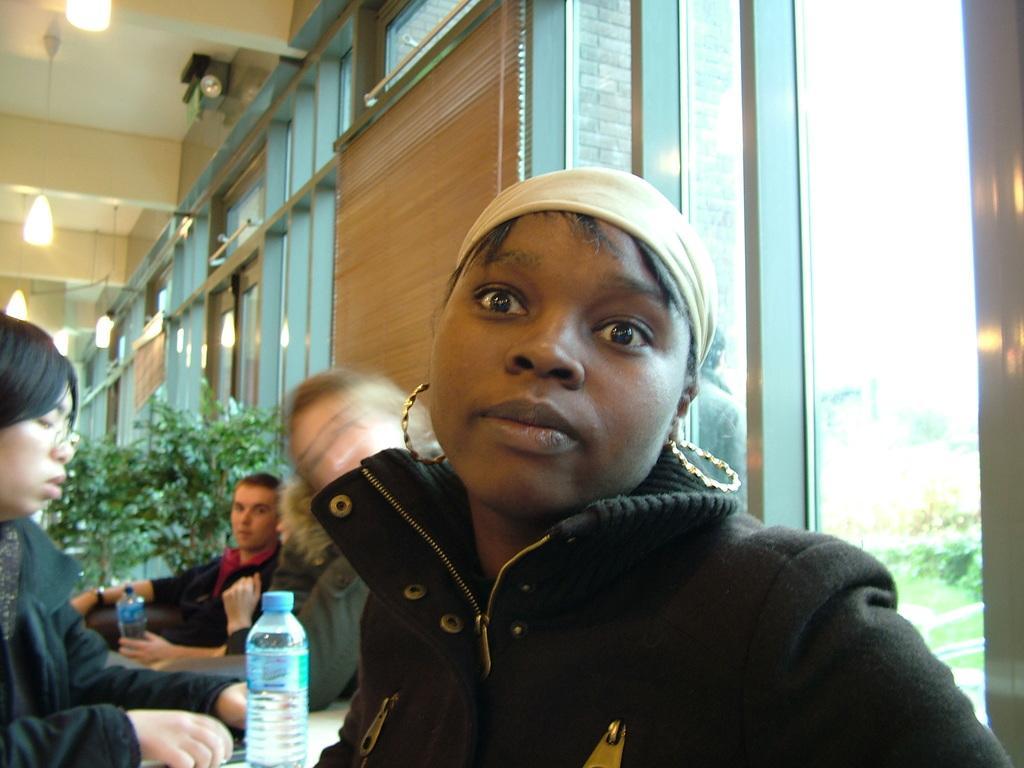Could you give a brief overview of what you see in this image? This image is taken inside the room. There is a woman wearing a black coat is wearing earrings. There is a bottle at the bottom of image. There are few people sitting at her backside. There is a woman sitting at the left side of image. There are some plants. Lights are hanged from the wall 